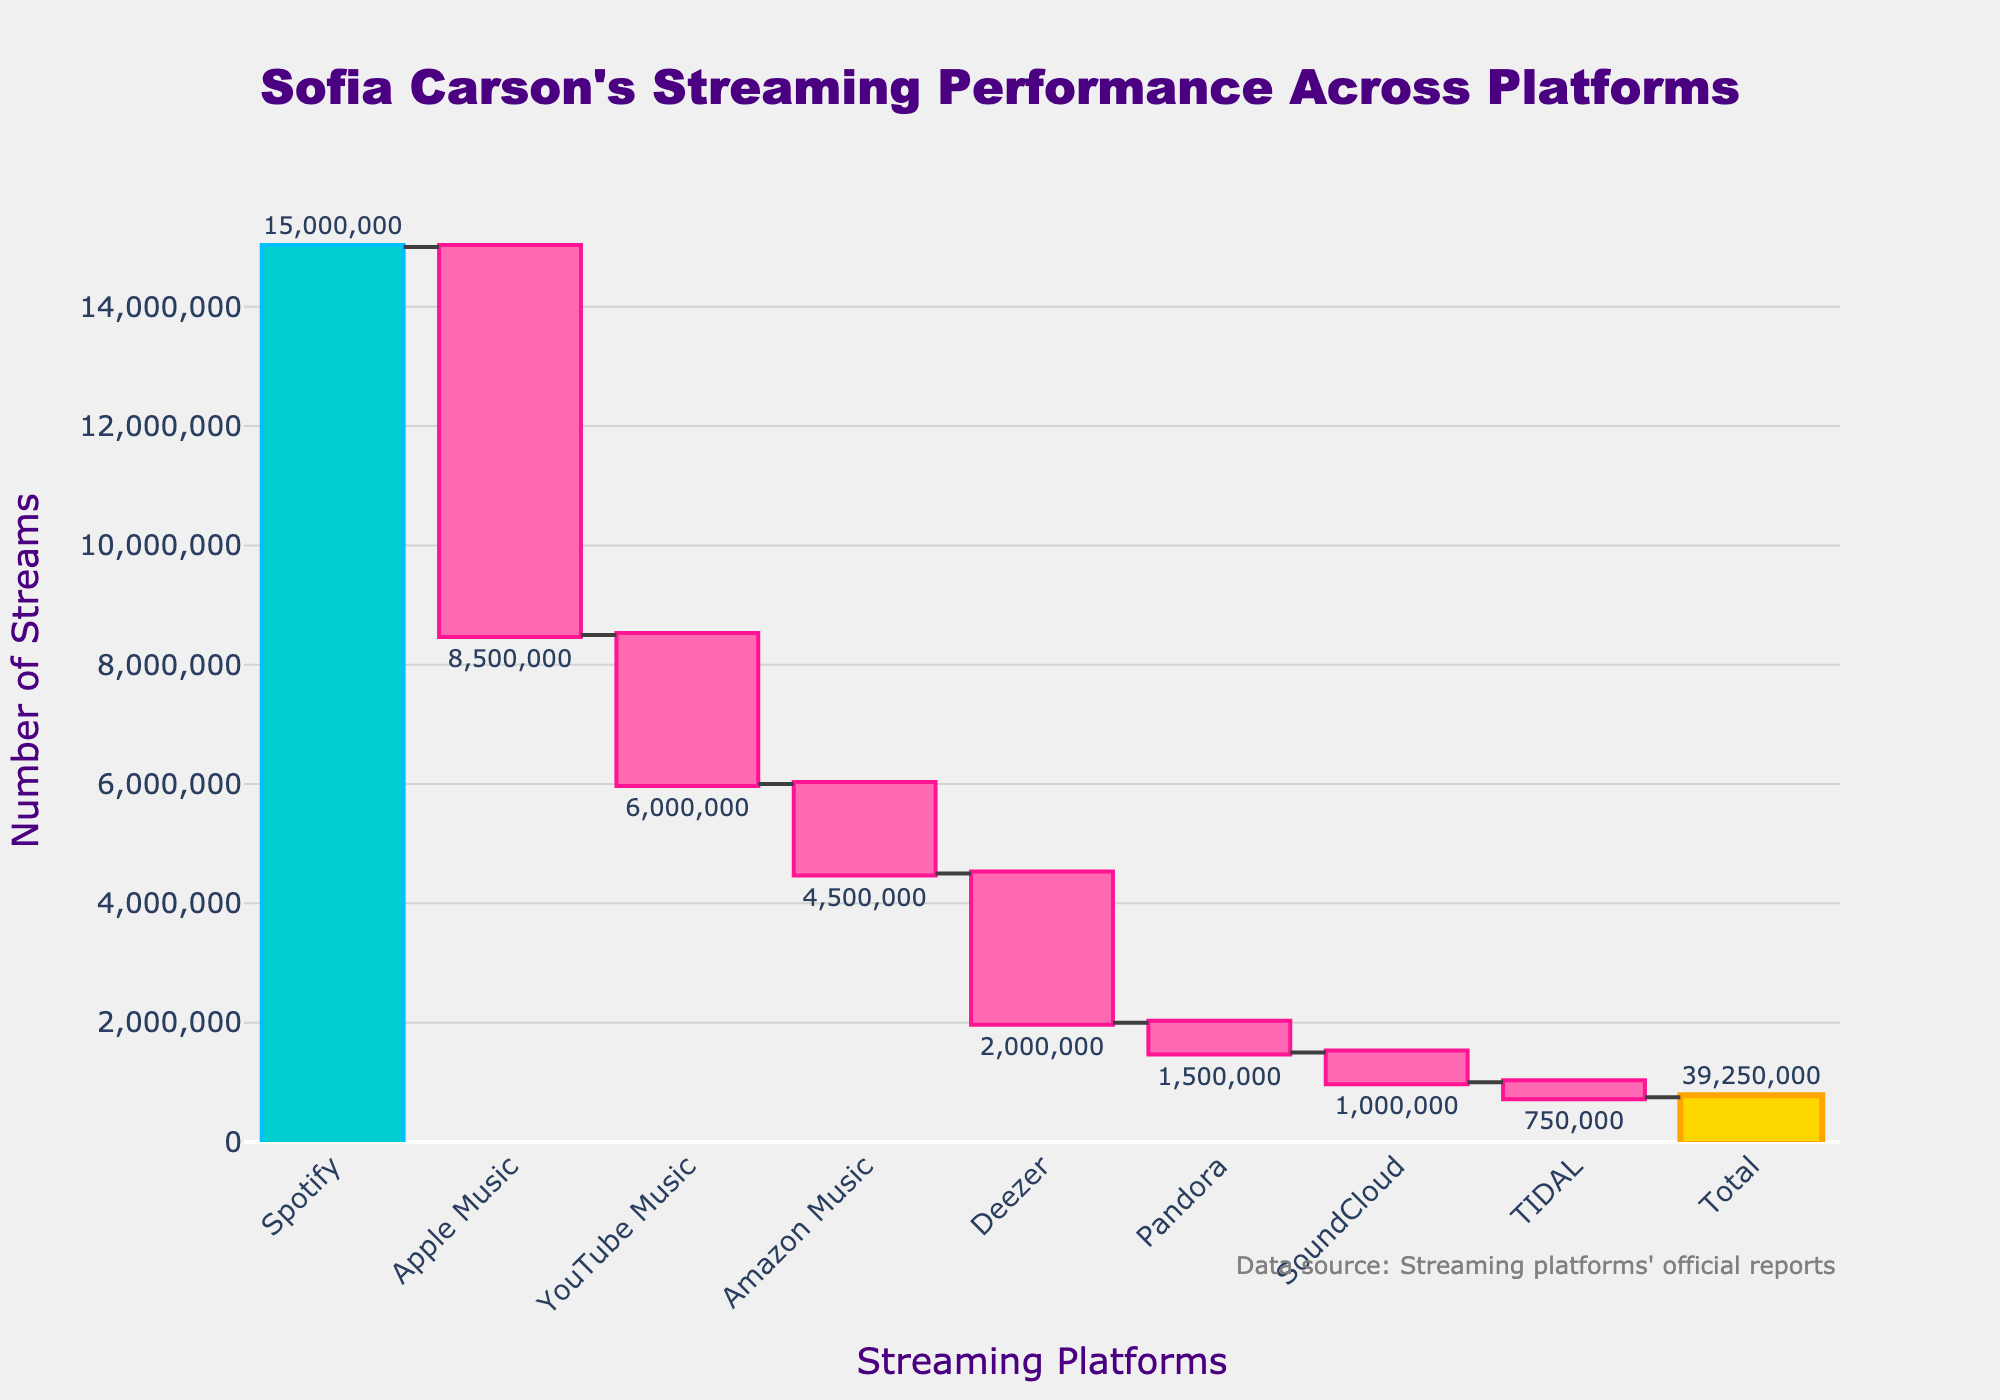What's the title of the chart? The title of the chart is prominently displayed at the top.
Answer: "Sofia Carson's Streaming Performance Across Platforms" Which platform has the highest number of streams? Examining the chart, the bar for Spotify is the tallest, indicating the highest number of streams.
Answer: Spotify How many streams did Apple Music lose compared to Spotify? The chart shows Apple Music's change as a decrease of 6,500,000 streams from Spotify's initial 15,000,000. Subtracting 6,500,000 from 15,000,000 gives this.
Answer: 6,500,000 What is the color used for the increase in streams? The increasing bars are highlighted with a distinct color to show growth, here it is a unique shade of turquoise.
Answer: Turquoise What is the total number of streams across all platforms? The chart has a total column that sums all streams from different platforms, indicated in golden color.
Answer: 39,250,000 Which platforms have a decrease in streams? Platforms with decreasing streams are marked with pink bars on the chart.
Answer: Apple Music, YouTube Music, Amazon Music, Deezer, Pandora, SoundCloud, TIDAL How many streams did YouTube Music have? The bar for YouTube Music starts at the end of Apple Music’s bar and decreases by 2,500,000, making it 6,000,000 streams.
Answer: 6,000,000 What's the cumulative change in streams from Spotify to Amazon Music? Adding up the decreases: Apple Music (-6.5M), YouTube Music (-2.5M), Amazon Music (-1.5M) from Spotify's initial value gives the cumulative change.
Answer: -10,500,000 Which platform contributed the least to the total streams? Observing the shortest bar indicates the least contribution, which belongs to TIDAL.
Answer: TIDAL What is the percentage decrease in streams from Spotify to Deezer? First, calculate the total decrease from Spotify (15,000,000) to Deezer (2,000,000 streams). The % decrease from Spotify is (15,000,000 - 2,000,000)/15,000,000*100.
Answer: 86.67% 